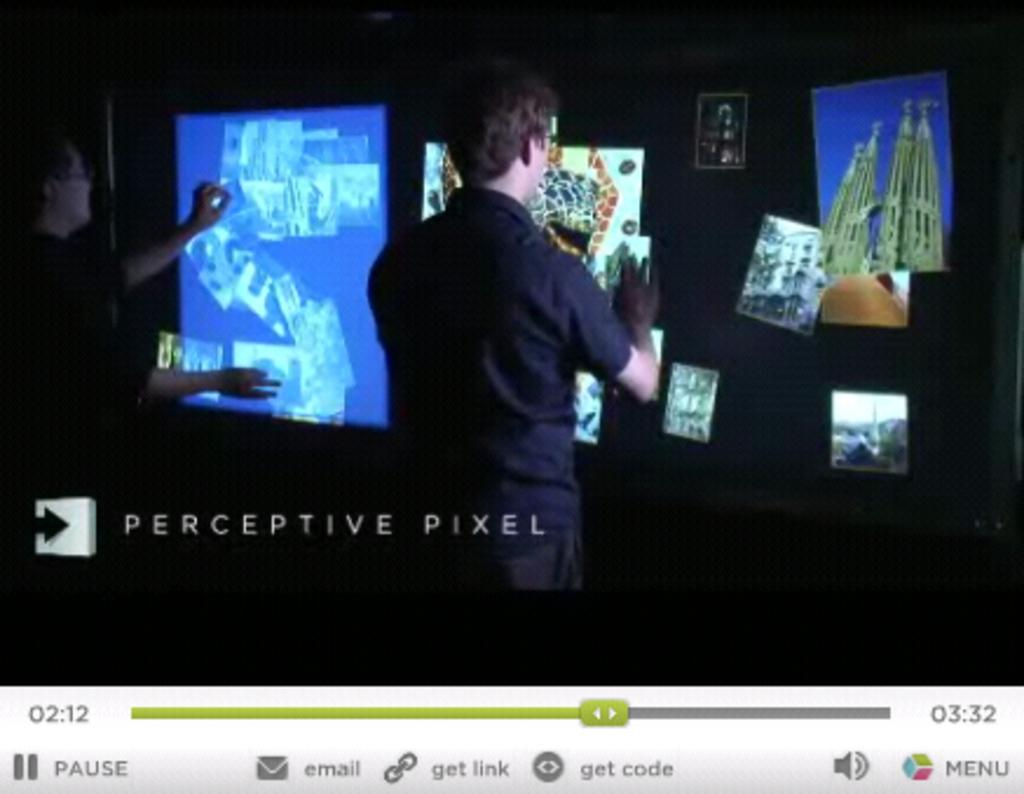Provide a one-sentence caption for the provided image. A photo showing several photos that is labeled Perceptive Pixel. 